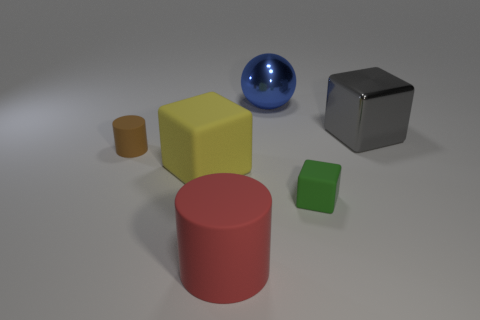What is the shape of the metal thing that is behind the big cube that is right of the object that is behind the big metal block?
Give a very brief answer. Sphere. There is a big object that is both to the left of the big blue metallic sphere and behind the big red cylinder; what is it made of?
Your response must be concise. Rubber. There is a large thing that is to the right of the tiny matte thing to the right of the brown object that is behind the small cube; what is its color?
Ensure brevity in your answer.  Gray. How many purple things are large spheres or small things?
Provide a succinct answer. 0. What number of other things are the same size as the green matte object?
Make the answer very short. 1. How many large purple cubes are there?
Your answer should be compact. 0. Is there anything else that has the same shape as the large gray thing?
Your answer should be compact. Yes. Is the big block in front of the tiny rubber cylinder made of the same material as the big object that is on the right side of the green rubber cube?
Make the answer very short. No. What is the material of the small cylinder?
Your answer should be very brief. Rubber. How many small cylinders have the same material as the brown object?
Offer a very short reply. 0. 